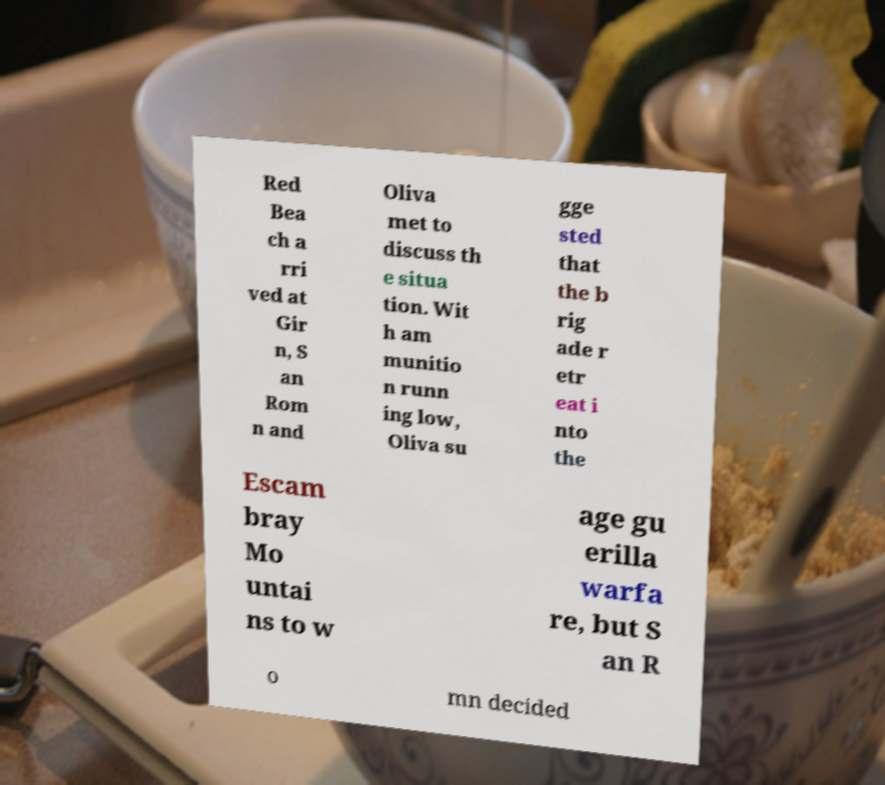Can you accurately transcribe the text from the provided image for me? Red Bea ch a rri ved at Gir n, S an Rom n and Oliva met to discuss th e situa tion. Wit h am munitio n runn ing low, Oliva su gge sted that the b rig ade r etr eat i nto the Escam bray Mo untai ns to w age gu erilla warfa re, but S an R o mn decided 